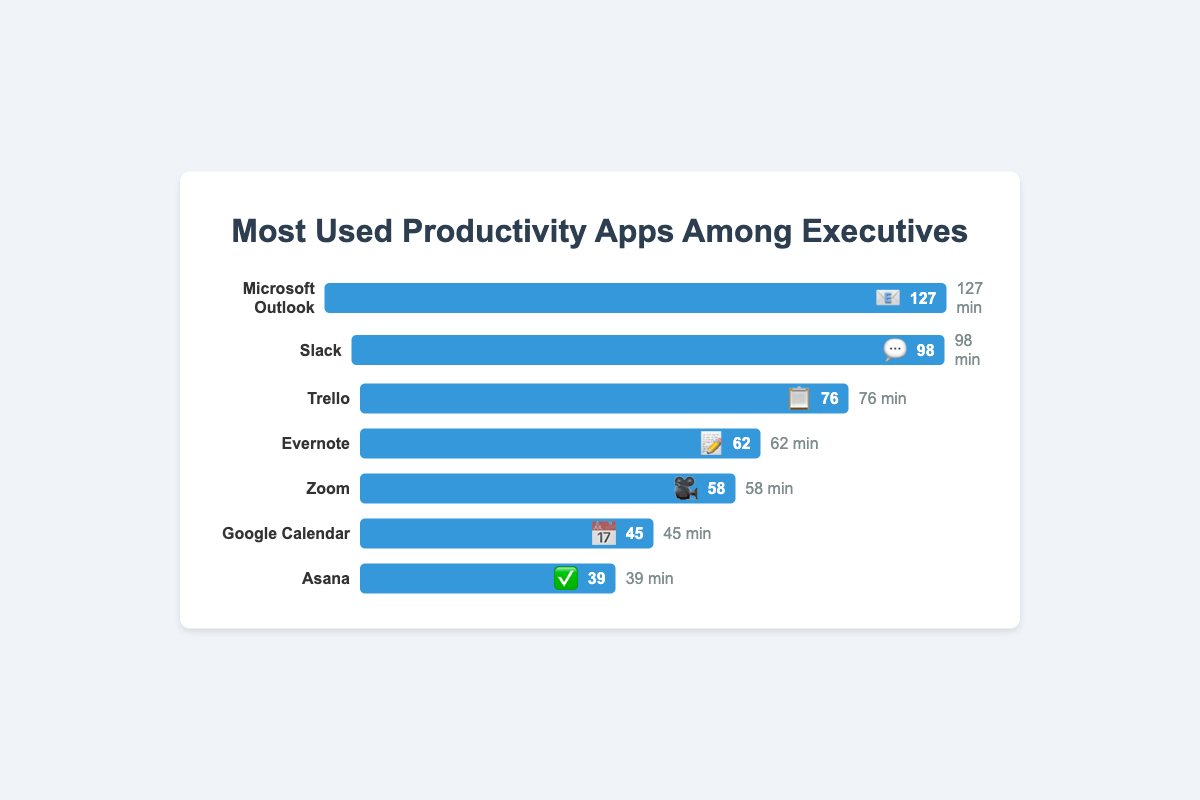Which productivity app has the highest average daily usage time? The app with the longest blue bar represents the highest average daily usage. In this case, it is Microsoft Outlook with 127 minutes.
Answer: Microsoft Outlook Which app is used more daily, Slack or Trello? Compare the average daily usage times of Slack (98 minutes) and Trello (76 minutes). Slack has a higher average daily usage time.
Answer: Slack What's the total average daily usage time for Evernote and Zoom combined? Add the average daily usage times of Evernote (62 minutes) and Zoom (58 minutes). The total is 62 + 58 = 120 minutes.
Answer: 120 minutes How much more time is spent on Slack compared to Google Calendar? Subtract the average daily usage of Google Calendar (45 minutes) from Slack (98 minutes): 98 - 45 = 53 minutes.
Answer: 53 minutes Rank the apps in order of average daily usage from highest to lowest. List the apps in descending order based on their average daily usage times: Microsoft Outlook (127), Slack (98), Trello (76), Evernote (62), Zoom (58), Google Calendar (45), Asana (39).
Answer: Microsoft Outlook, Slack, Trello, Evernote, Zoom, Google Calendar, Asana Which app has the lowest average daily usage time? Identify the app with the shortest blue bar, which is Asana with 39 minutes.
Answer: Asana Is the average daily usage time of Trello greater than Evernote's by more than 10 minutes? Subtract Evernote's time (62 minutes) from Trello's time (76 minutes): 76 - 62 = 14 minutes. Since 14 is greater than 10, the answer is yes.
Answer: Yes What is the combined average daily usage time for all the apps? Sum the average daily usage times for all the apps: 127 (Outlook) + 98 (Slack) + 76 (Trello) + 62 (Evernote) + 58 (Zoom) + 45 (Google Calendar) + 39 (Asana) = 505 minutes.
Answer: 505 minutes Which app represented by a calendar emoji has an average daily usage time? Look for the emoji representing a calendar (📅), which corresponds to Google Calendar with an average daily usage of 45 minutes.
Answer: Google Calendar Compare the usage time difference between the most used app and the least used app. Subtract the least used app (Asana with 39 minutes) from the most used app (Microsoft Outlook with 127 minutes): 127 - 39 = 88 minutes.
Answer: 88 minutes 